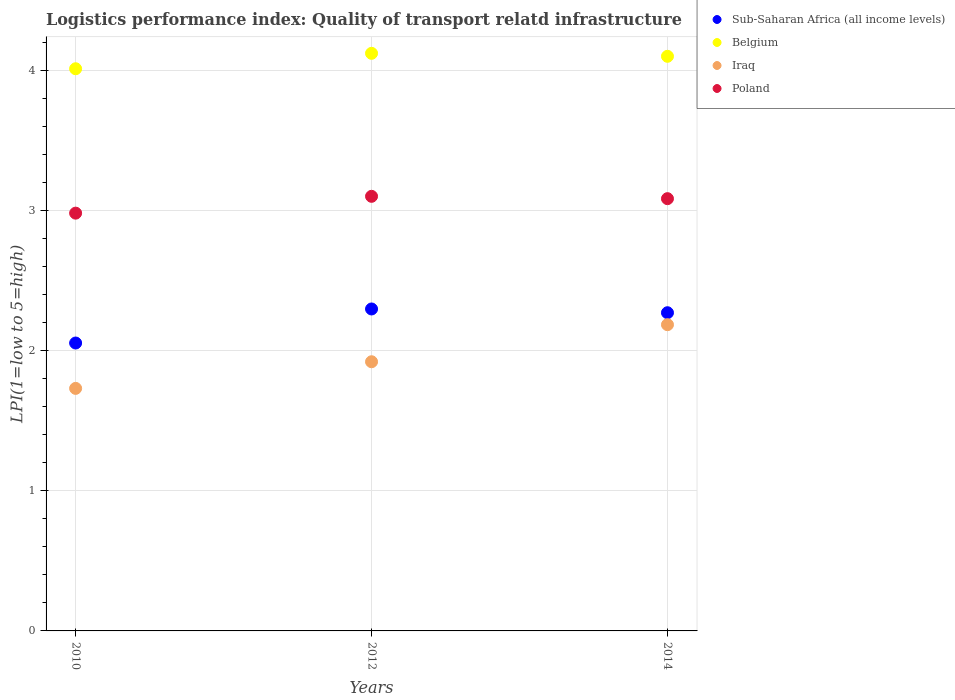What is the logistics performance index in Poland in 2014?
Give a very brief answer. 3.08. Across all years, what is the minimum logistics performance index in Poland?
Offer a terse response. 2.98. What is the total logistics performance index in Sub-Saharan Africa (all income levels) in the graph?
Your response must be concise. 6.62. What is the difference between the logistics performance index in Poland in 2010 and that in 2012?
Provide a short and direct response. -0.12. What is the difference between the logistics performance index in Iraq in 2014 and the logistics performance index in Poland in 2010?
Keep it short and to the point. -0.8. What is the average logistics performance index in Iraq per year?
Give a very brief answer. 1.94. In the year 2010, what is the difference between the logistics performance index in Iraq and logistics performance index in Poland?
Offer a terse response. -1.25. What is the ratio of the logistics performance index in Poland in 2010 to that in 2012?
Ensure brevity in your answer.  0.96. Is the difference between the logistics performance index in Iraq in 2010 and 2012 greater than the difference between the logistics performance index in Poland in 2010 and 2012?
Keep it short and to the point. No. What is the difference between the highest and the second highest logistics performance index in Belgium?
Ensure brevity in your answer.  0.02. What is the difference between the highest and the lowest logistics performance index in Sub-Saharan Africa (all income levels)?
Your answer should be compact. 0.24. In how many years, is the logistics performance index in Iraq greater than the average logistics performance index in Iraq taken over all years?
Your answer should be compact. 1. Is the sum of the logistics performance index in Poland in 2010 and 2012 greater than the maximum logistics performance index in Belgium across all years?
Your answer should be very brief. Yes. Is it the case that in every year, the sum of the logistics performance index in Belgium and logistics performance index in Poland  is greater than the sum of logistics performance index in Sub-Saharan Africa (all income levels) and logistics performance index in Iraq?
Give a very brief answer. Yes. Is the logistics performance index in Iraq strictly less than the logistics performance index in Sub-Saharan Africa (all income levels) over the years?
Your answer should be very brief. Yes. How many dotlines are there?
Keep it short and to the point. 4. How many years are there in the graph?
Offer a terse response. 3. Are the values on the major ticks of Y-axis written in scientific E-notation?
Provide a short and direct response. No. Does the graph contain grids?
Your answer should be compact. Yes. Where does the legend appear in the graph?
Make the answer very short. Top right. How many legend labels are there?
Your response must be concise. 4. How are the legend labels stacked?
Your answer should be compact. Vertical. What is the title of the graph?
Make the answer very short. Logistics performance index: Quality of transport relatd infrastructure. What is the label or title of the X-axis?
Provide a succinct answer. Years. What is the label or title of the Y-axis?
Make the answer very short. LPI(1=low to 5=high). What is the LPI(1=low to 5=high) in Sub-Saharan Africa (all income levels) in 2010?
Ensure brevity in your answer.  2.05. What is the LPI(1=low to 5=high) in Belgium in 2010?
Provide a short and direct response. 4.01. What is the LPI(1=low to 5=high) in Iraq in 2010?
Make the answer very short. 1.73. What is the LPI(1=low to 5=high) in Poland in 2010?
Make the answer very short. 2.98. What is the LPI(1=low to 5=high) in Sub-Saharan Africa (all income levels) in 2012?
Provide a short and direct response. 2.3. What is the LPI(1=low to 5=high) in Belgium in 2012?
Give a very brief answer. 4.12. What is the LPI(1=low to 5=high) of Iraq in 2012?
Provide a short and direct response. 1.92. What is the LPI(1=low to 5=high) of Sub-Saharan Africa (all income levels) in 2014?
Ensure brevity in your answer.  2.27. What is the LPI(1=low to 5=high) of Belgium in 2014?
Offer a terse response. 4.1. What is the LPI(1=low to 5=high) in Iraq in 2014?
Your answer should be compact. 2.18. What is the LPI(1=low to 5=high) of Poland in 2014?
Make the answer very short. 3.08. Across all years, what is the maximum LPI(1=low to 5=high) of Sub-Saharan Africa (all income levels)?
Your answer should be compact. 2.3. Across all years, what is the maximum LPI(1=low to 5=high) in Belgium?
Offer a very short reply. 4.12. Across all years, what is the maximum LPI(1=low to 5=high) in Iraq?
Offer a very short reply. 2.18. Across all years, what is the minimum LPI(1=low to 5=high) in Sub-Saharan Africa (all income levels)?
Give a very brief answer. 2.05. Across all years, what is the minimum LPI(1=low to 5=high) in Belgium?
Your answer should be very brief. 4.01. Across all years, what is the minimum LPI(1=low to 5=high) of Iraq?
Make the answer very short. 1.73. Across all years, what is the minimum LPI(1=low to 5=high) of Poland?
Your answer should be very brief. 2.98. What is the total LPI(1=low to 5=high) of Sub-Saharan Africa (all income levels) in the graph?
Keep it short and to the point. 6.62. What is the total LPI(1=low to 5=high) of Belgium in the graph?
Ensure brevity in your answer.  12.23. What is the total LPI(1=low to 5=high) in Iraq in the graph?
Your response must be concise. 5.83. What is the total LPI(1=low to 5=high) in Poland in the graph?
Keep it short and to the point. 9.16. What is the difference between the LPI(1=low to 5=high) of Sub-Saharan Africa (all income levels) in 2010 and that in 2012?
Keep it short and to the point. -0.24. What is the difference between the LPI(1=low to 5=high) of Belgium in 2010 and that in 2012?
Keep it short and to the point. -0.11. What is the difference between the LPI(1=low to 5=high) of Iraq in 2010 and that in 2012?
Offer a very short reply. -0.19. What is the difference between the LPI(1=low to 5=high) of Poland in 2010 and that in 2012?
Your answer should be very brief. -0.12. What is the difference between the LPI(1=low to 5=high) in Sub-Saharan Africa (all income levels) in 2010 and that in 2014?
Keep it short and to the point. -0.22. What is the difference between the LPI(1=low to 5=high) in Belgium in 2010 and that in 2014?
Your answer should be very brief. -0.09. What is the difference between the LPI(1=low to 5=high) in Iraq in 2010 and that in 2014?
Provide a short and direct response. -0.45. What is the difference between the LPI(1=low to 5=high) in Poland in 2010 and that in 2014?
Provide a short and direct response. -0.1. What is the difference between the LPI(1=low to 5=high) of Sub-Saharan Africa (all income levels) in 2012 and that in 2014?
Your response must be concise. 0.03. What is the difference between the LPI(1=low to 5=high) of Belgium in 2012 and that in 2014?
Offer a very short reply. 0.02. What is the difference between the LPI(1=low to 5=high) of Iraq in 2012 and that in 2014?
Ensure brevity in your answer.  -0.26. What is the difference between the LPI(1=low to 5=high) of Poland in 2012 and that in 2014?
Your answer should be very brief. 0.02. What is the difference between the LPI(1=low to 5=high) of Sub-Saharan Africa (all income levels) in 2010 and the LPI(1=low to 5=high) of Belgium in 2012?
Your response must be concise. -2.07. What is the difference between the LPI(1=low to 5=high) of Sub-Saharan Africa (all income levels) in 2010 and the LPI(1=low to 5=high) of Iraq in 2012?
Ensure brevity in your answer.  0.13. What is the difference between the LPI(1=low to 5=high) of Sub-Saharan Africa (all income levels) in 2010 and the LPI(1=low to 5=high) of Poland in 2012?
Your response must be concise. -1.05. What is the difference between the LPI(1=low to 5=high) of Belgium in 2010 and the LPI(1=low to 5=high) of Iraq in 2012?
Provide a succinct answer. 2.09. What is the difference between the LPI(1=low to 5=high) in Belgium in 2010 and the LPI(1=low to 5=high) in Poland in 2012?
Give a very brief answer. 0.91. What is the difference between the LPI(1=low to 5=high) of Iraq in 2010 and the LPI(1=low to 5=high) of Poland in 2012?
Offer a terse response. -1.37. What is the difference between the LPI(1=low to 5=high) in Sub-Saharan Africa (all income levels) in 2010 and the LPI(1=low to 5=high) in Belgium in 2014?
Provide a short and direct response. -2.05. What is the difference between the LPI(1=low to 5=high) in Sub-Saharan Africa (all income levels) in 2010 and the LPI(1=low to 5=high) in Iraq in 2014?
Your answer should be compact. -0.13. What is the difference between the LPI(1=low to 5=high) in Sub-Saharan Africa (all income levels) in 2010 and the LPI(1=low to 5=high) in Poland in 2014?
Make the answer very short. -1.03. What is the difference between the LPI(1=low to 5=high) of Belgium in 2010 and the LPI(1=low to 5=high) of Iraq in 2014?
Give a very brief answer. 1.83. What is the difference between the LPI(1=low to 5=high) of Belgium in 2010 and the LPI(1=low to 5=high) of Poland in 2014?
Provide a succinct answer. 0.93. What is the difference between the LPI(1=low to 5=high) of Iraq in 2010 and the LPI(1=low to 5=high) of Poland in 2014?
Your response must be concise. -1.35. What is the difference between the LPI(1=low to 5=high) of Sub-Saharan Africa (all income levels) in 2012 and the LPI(1=low to 5=high) of Belgium in 2014?
Your answer should be compact. -1.8. What is the difference between the LPI(1=low to 5=high) of Sub-Saharan Africa (all income levels) in 2012 and the LPI(1=low to 5=high) of Iraq in 2014?
Ensure brevity in your answer.  0.11. What is the difference between the LPI(1=low to 5=high) in Sub-Saharan Africa (all income levels) in 2012 and the LPI(1=low to 5=high) in Poland in 2014?
Your response must be concise. -0.79. What is the difference between the LPI(1=low to 5=high) of Belgium in 2012 and the LPI(1=low to 5=high) of Iraq in 2014?
Your answer should be compact. 1.94. What is the difference between the LPI(1=low to 5=high) in Belgium in 2012 and the LPI(1=low to 5=high) in Poland in 2014?
Provide a succinct answer. 1.04. What is the difference between the LPI(1=low to 5=high) in Iraq in 2012 and the LPI(1=low to 5=high) in Poland in 2014?
Your answer should be compact. -1.16. What is the average LPI(1=low to 5=high) in Sub-Saharan Africa (all income levels) per year?
Give a very brief answer. 2.21. What is the average LPI(1=low to 5=high) of Belgium per year?
Your answer should be compact. 4.08. What is the average LPI(1=low to 5=high) in Iraq per year?
Your answer should be very brief. 1.94. What is the average LPI(1=low to 5=high) of Poland per year?
Make the answer very short. 3.05. In the year 2010, what is the difference between the LPI(1=low to 5=high) of Sub-Saharan Africa (all income levels) and LPI(1=low to 5=high) of Belgium?
Keep it short and to the point. -1.96. In the year 2010, what is the difference between the LPI(1=low to 5=high) in Sub-Saharan Africa (all income levels) and LPI(1=low to 5=high) in Iraq?
Offer a very short reply. 0.32. In the year 2010, what is the difference between the LPI(1=low to 5=high) in Sub-Saharan Africa (all income levels) and LPI(1=low to 5=high) in Poland?
Make the answer very short. -0.93. In the year 2010, what is the difference between the LPI(1=low to 5=high) of Belgium and LPI(1=low to 5=high) of Iraq?
Offer a very short reply. 2.28. In the year 2010, what is the difference between the LPI(1=low to 5=high) in Belgium and LPI(1=low to 5=high) in Poland?
Your answer should be compact. 1.03. In the year 2010, what is the difference between the LPI(1=low to 5=high) in Iraq and LPI(1=low to 5=high) in Poland?
Provide a short and direct response. -1.25. In the year 2012, what is the difference between the LPI(1=low to 5=high) of Sub-Saharan Africa (all income levels) and LPI(1=low to 5=high) of Belgium?
Your answer should be very brief. -1.82. In the year 2012, what is the difference between the LPI(1=low to 5=high) in Sub-Saharan Africa (all income levels) and LPI(1=low to 5=high) in Iraq?
Your response must be concise. 0.38. In the year 2012, what is the difference between the LPI(1=low to 5=high) in Sub-Saharan Africa (all income levels) and LPI(1=low to 5=high) in Poland?
Provide a short and direct response. -0.8. In the year 2012, what is the difference between the LPI(1=low to 5=high) in Iraq and LPI(1=low to 5=high) in Poland?
Offer a terse response. -1.18. In the year 2014, what is the difference between the LPI(1=low to 5=high) of Sub-Saharan Africa (all income levels) and LPI(1=low to 5=high) of Belgium?
Your response must be concise. -1.83. In the year 2014, what is the difference between the LPI(1=low to 5=high) in Sub-Saharan Africa (all income levels) and LPI(1=low to 5=high) in Iraq?
Offer a very short reply. 0.09. In the year 2014, what is the difference between the LPI(1=low to 5=high) in Sub-Saharan Africa (all income levels) and LPI(1=low to 5=high) in Poland?
Your answer should be very brief. -0.81. In the year 2014, what is the difference between the LPI(1=low to 5=high) of Belgium and LPI(1=low to 5=high) of Iraq?
Provide a short and direct response. 1.91. In the year 2014, what is the difference between the LPI(1=low to 5=high) in Belgium and LPI(1=low to 5=high) in Poland?
Your answer should be compact. 1.02. In the year 2014, what is the difference between the LPI(1=low to 5=high) of Iraq and LPI(1=low to 5=high) of Poland?
Make the answer very short. -0.9. What is the ratio of the LPI(1=low to 5=high) of Sub-Saharan Africa (all income levels) in 2010 to that in 2012?
Offer a terse response. 0.89. What is the ratio of the LPI(1=low to 5=high) of Belgium in 2010 to that in 2012?
Your response must be concise. 0.97. What is the ratio of the LPI(1=low to 5=high) in Iraq in 2010 to that in 2012?
Offer a very short reply. 0.9. What is the ratio of the LPI(1=low to 5=high) in Poland in 2010 to that in 2012?
Ensure brevity in your answer.  0.96. What is the ratio of the LPI(1=low to 5=high) in Sub-Saharan Africa (all income levels) in 2010 to that in 2014?
Keep it short and to the point. 0.9. What is the ratio of the LPI(1=low to 5=high) in Belgium in 2010 to that in 2014?
Make the answer very short. 0.98. What is the ratio of the LPI(1=low to 5=high) of Iraq in 2010 to that in 2014?
Offer a very short reply. 0.79. What is the ratio of the LPI(1=low to 5=high) in Poland in 2010 to that in 2014?
Keep it short and to the point. 0.97. What is the ratio of the LPI(1=low to 5=high) of Sub-Saharan Africa (all income levels) in 2012 to that in 2014?
Provide a short and direct response. 1.01. What is the ratio of the LPI(1=low to 5=high) of Iraq in 2012 to that in 2014?
Provide a succinct answer. 0.88. What is the ratio of the LPI(1=low to 5=high) of Poland in 2012 to that in 2014?
Your answer should be compact. 1.01. What is the difference between the highest and the second highest LPI(1=low to 5=high) of Sub-Saharan Africa (all income levels)?
Offer a terse response. 0.03. What is the difference between the highest and the second highest LPI(1=low to 5=high) in Belgium?
Keep it short and to the point. 0.02. What is the difference between the highest and the second highest LPI(1=low to 5=high) of Iraq?
Offer a terse response. 0.26. What is the difference between the highest and the second highest LPI(1=low to 5=high) in Poland?
Your response must be concise. 0.02. What is the difference between the highest and the lowest LPI(1=low to 5=high) of Sub-Saharan Africa (all income levels)?
Provide a short and direct response. 0.24. What is the difference between the highest and the lowest LPI(1=low to 5=high) in Belgium?
Offer a very short reply. 0.11. What is the difference between the highest and the lowest LPI(1=low to 5=high) of Iraq?
Give a very brief answer. 0.45. What is the difference between the highest and the lowest LPI(1=low to 5=high) in Poland?
Your answer should be very brief. 0.12. 